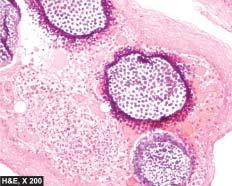what are the spores present in?
Answer the question using a single word or phrase. Sporangia as well as intermingled in the inflammatory cell infiltrate 